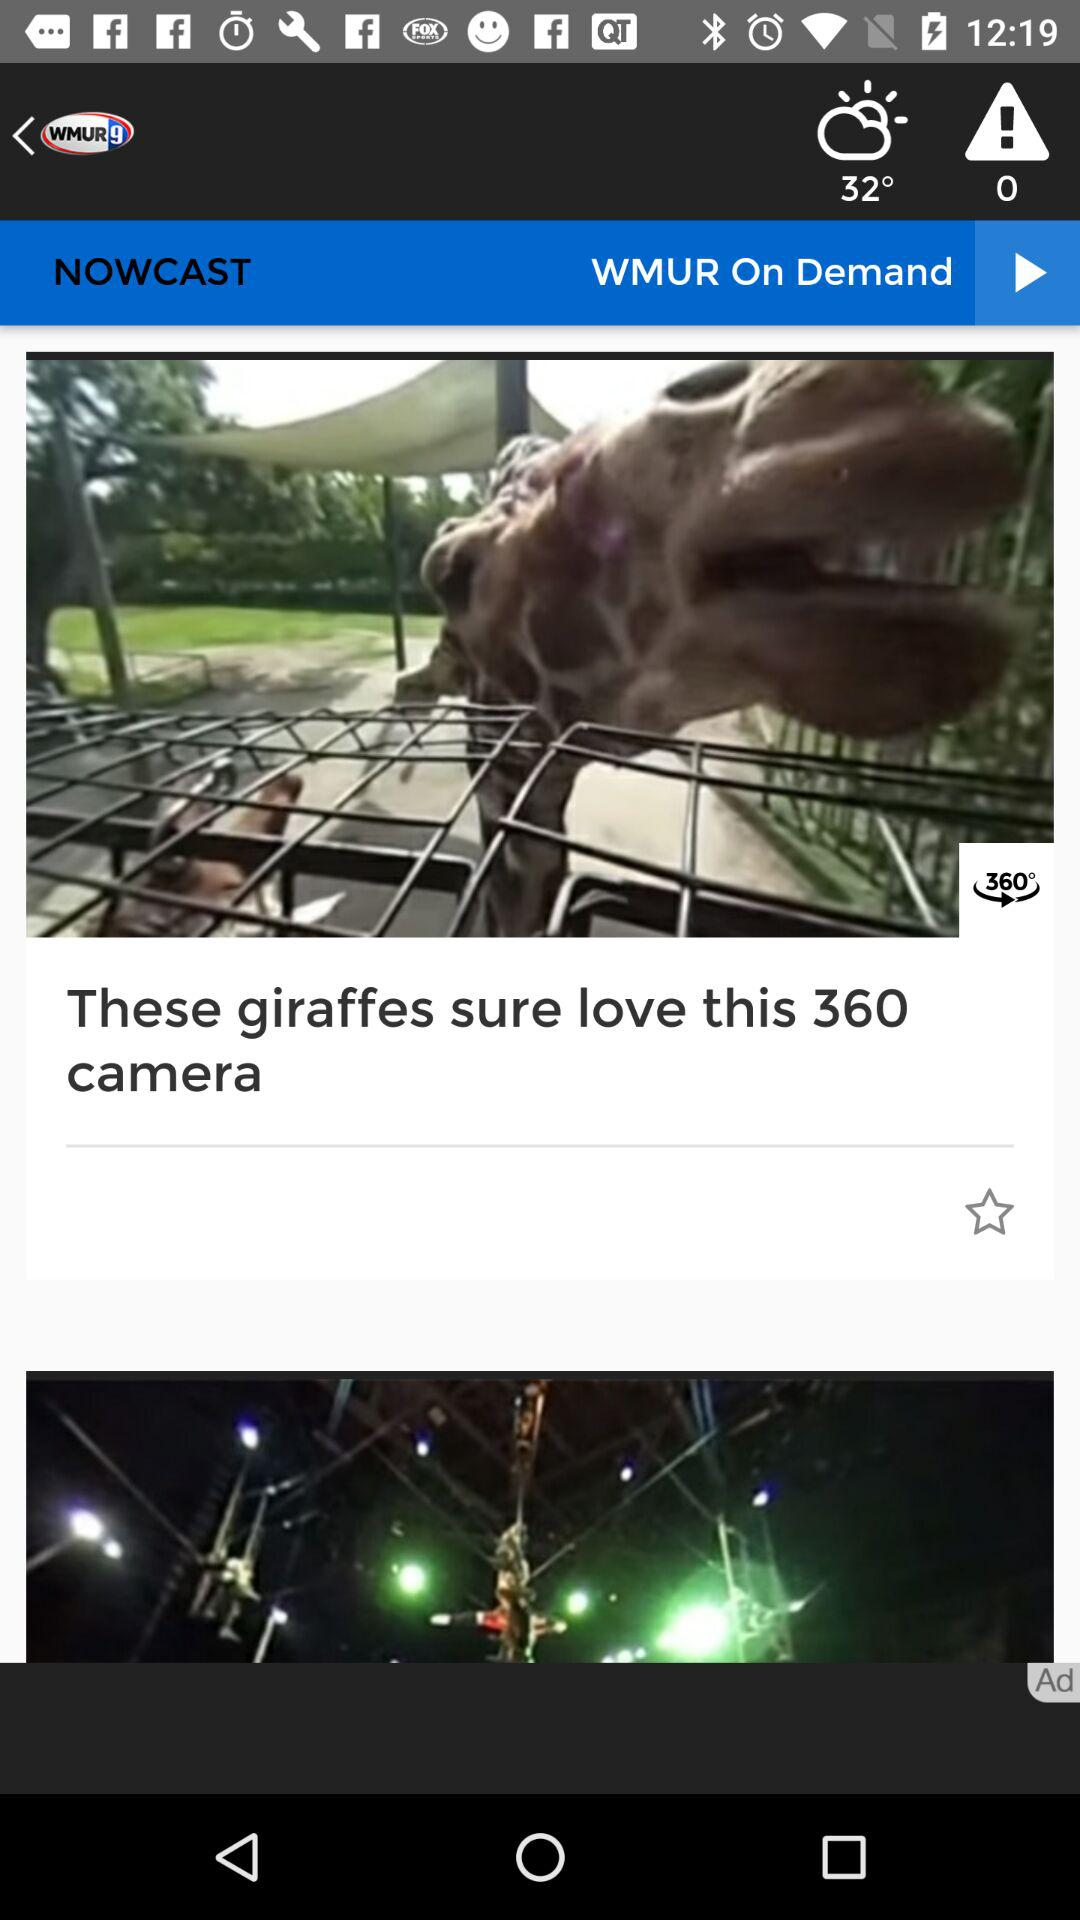What is the total count for the warning alerts? The total count for the warning alerts is 0. 